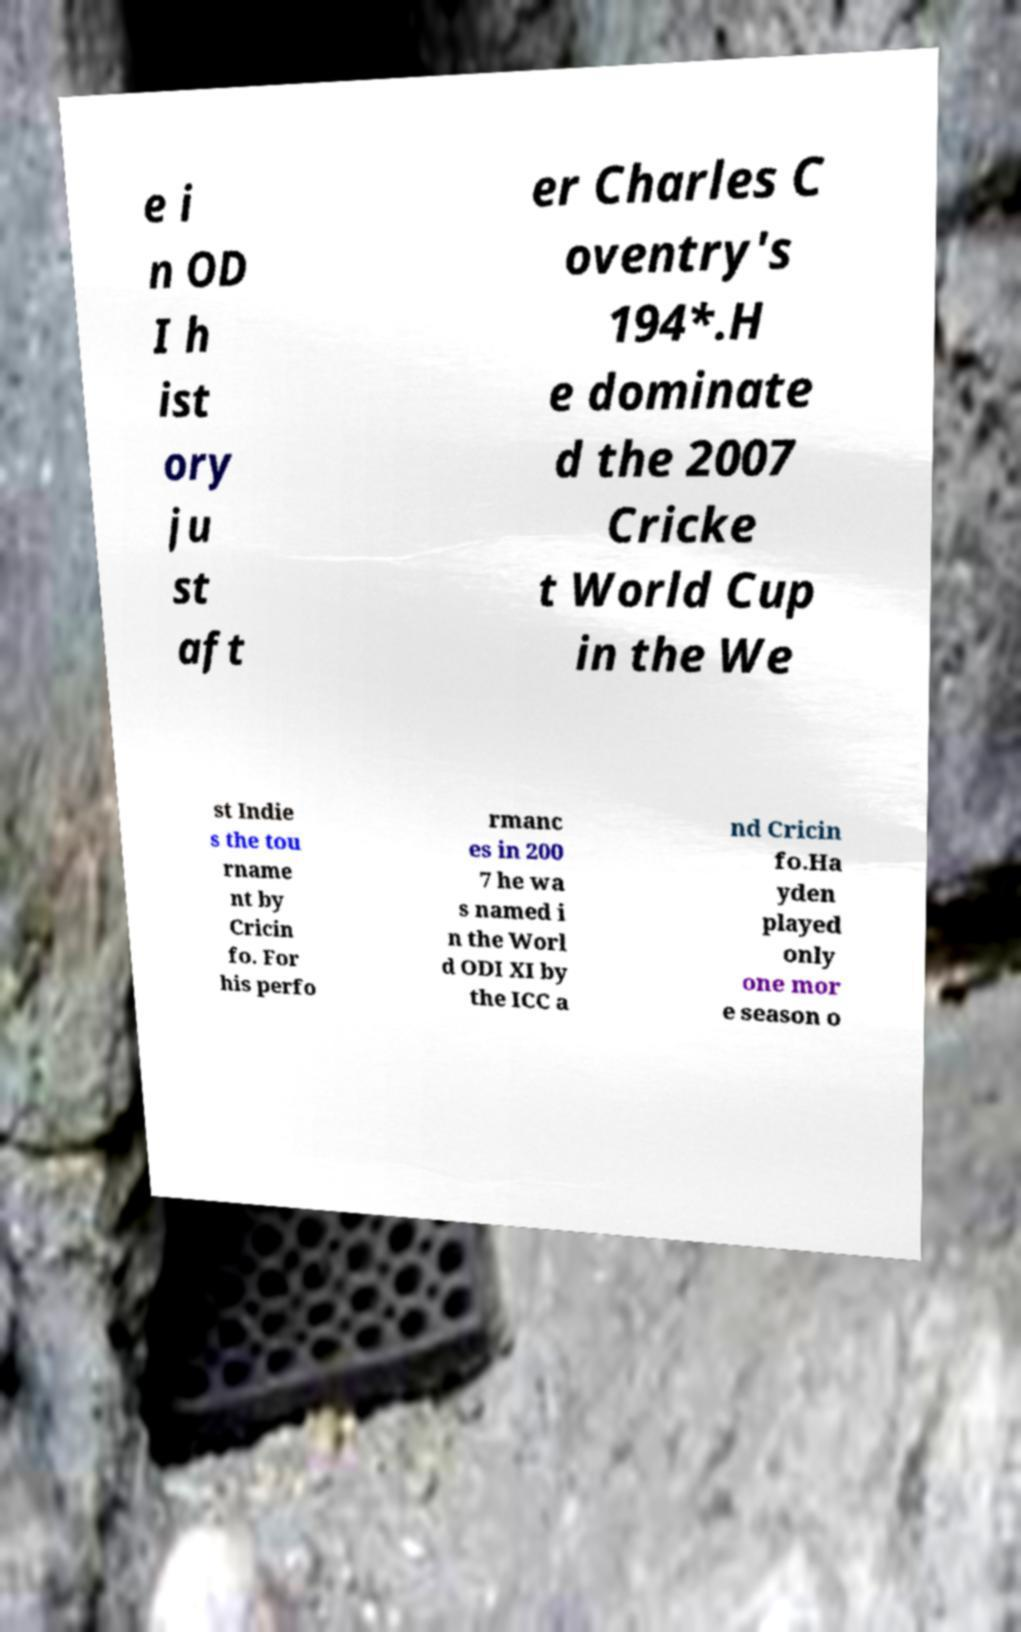Please read and relay the text visible in this image. What does it say? e i n OD I h ist ory ju st aft er Charles C oventry's 194*.H e dominate d the 2007 Cricke t World Cup in the We st Indie s the tou rname nt by Cricin fo. For his perfo rmanc es in 200 7 he wa s named i n the Worl d ODI XI by the ICC a nd Cricin fo.Ha yden played only one mor e season o 